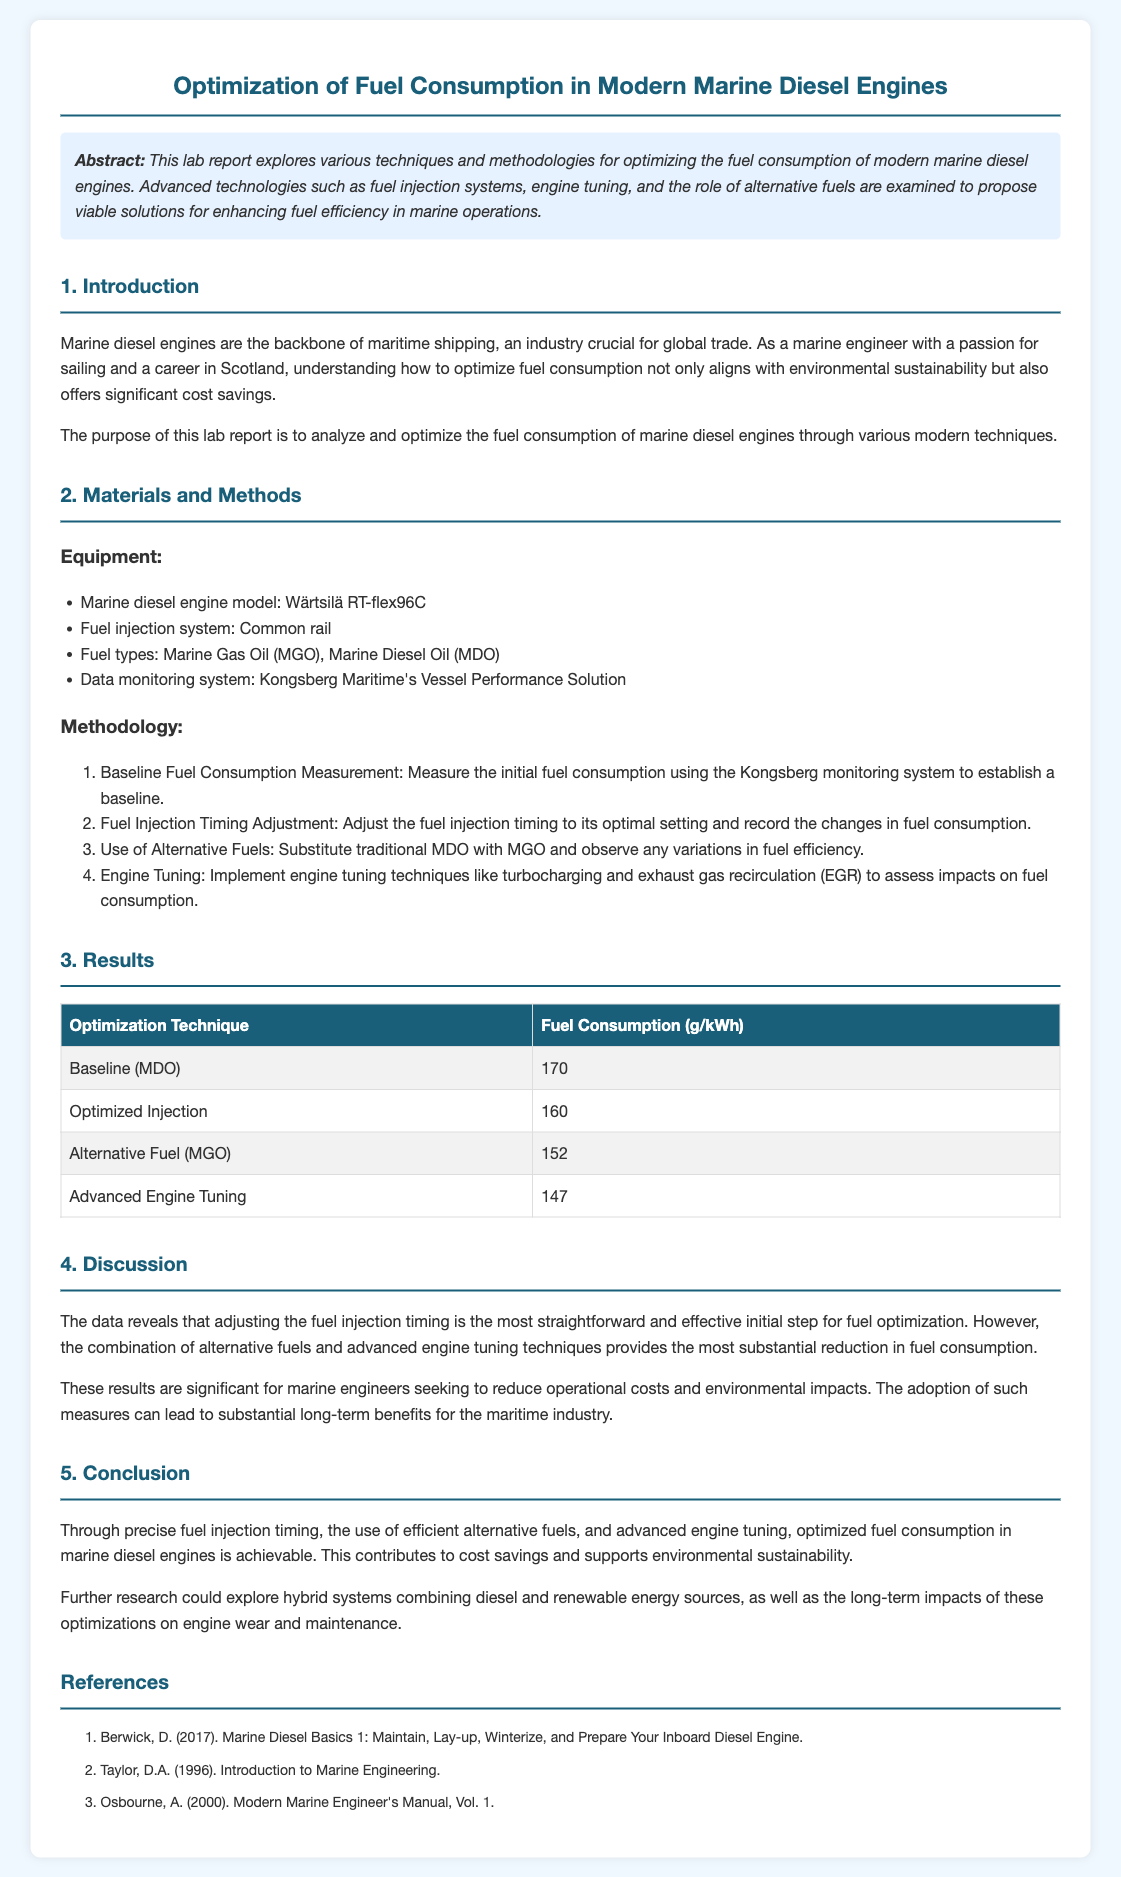what is the title of the lab report? The title is prominently displayed at the top of the document and states the focus of the study.
Answer: Optimization of Fuel Consumption in Modern Marine Diesel Engines who is the manufacturer of the marine diesel engine model used? The document mentions the specific engine model used in the study and its manufacturer clearly.
Answer: Wärtsilä what are the two types of fuel examined in the study? The fuels are listed under the equipment section in the materials and methods part, highlighting their significance in the research.
Answer: Marine Gas Oil (MGO), Marine Diesel Oil (MDO) what was the baseline fuel consumption measured in the study? The baseline fuel consumption is presented in the results table, illustrating the initial measurement before any optimization techniques were applied.
Answer: 170 which optimization technique showed the lowest fuel consumption? The results table indicates the comparison of various techniques and highlights the effectiveness of one specific technique regarding fuel consumption.
Answer: Advanced Engine Tuning what does the abstract emphasize about the report? The abstract briefly outlines the main focus and findings of the study, summarizing the techniques explored for fuel optimization.
Answer: Techniques and methodologies for optimizing fuel consumption why is selecting alternative fuels significant in fuel optimization? This reasoning goes beyond surface information, combining insights from different sections of the document about sustainability and efficiency.
Answer: Reduces fuel consumption substantially what is the purpose of this lab report? The purpose is stated in the introduction, detailing the intention behind conducting the study.
Answer: Analyze and optimize fuel consumption what recommendation is made for further research? The conclusion offers potential avenues for future exploration beyond the current study's findings, suggesting additional areas of investigation.
Answer: Hybrid systems combining diesel and renewable energy sources 